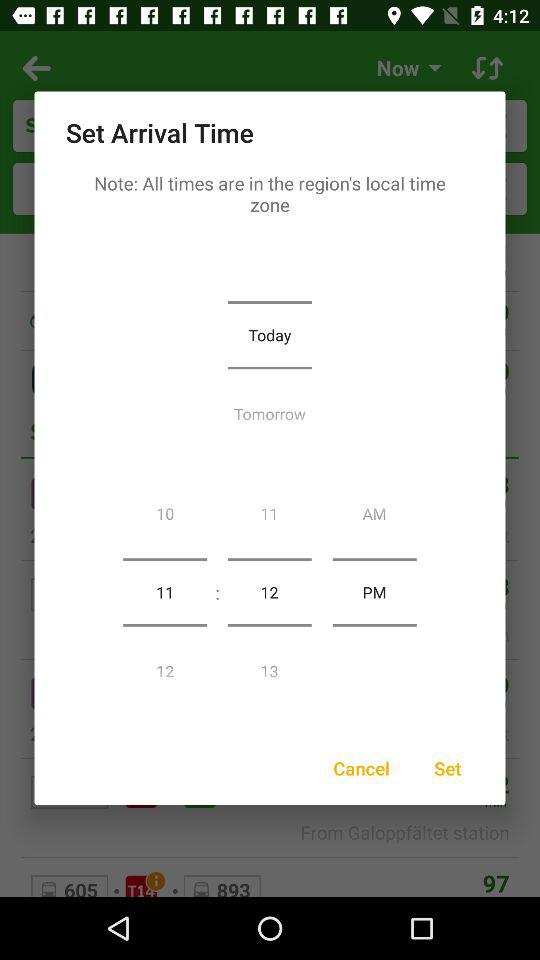How many hours are between the two 12's?
Answer the question using a single word or phrase. 1 